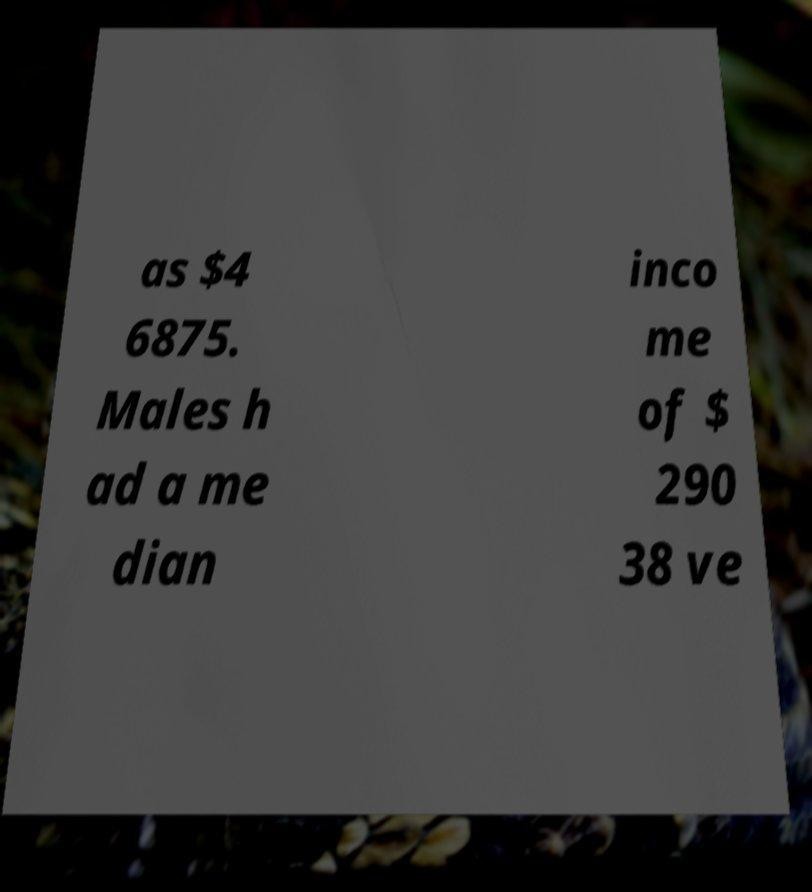I need the written content from this picture converted into text. Can you do that? as $4 6875. Males h ad a me dian inco me of $ 290 38 ve 